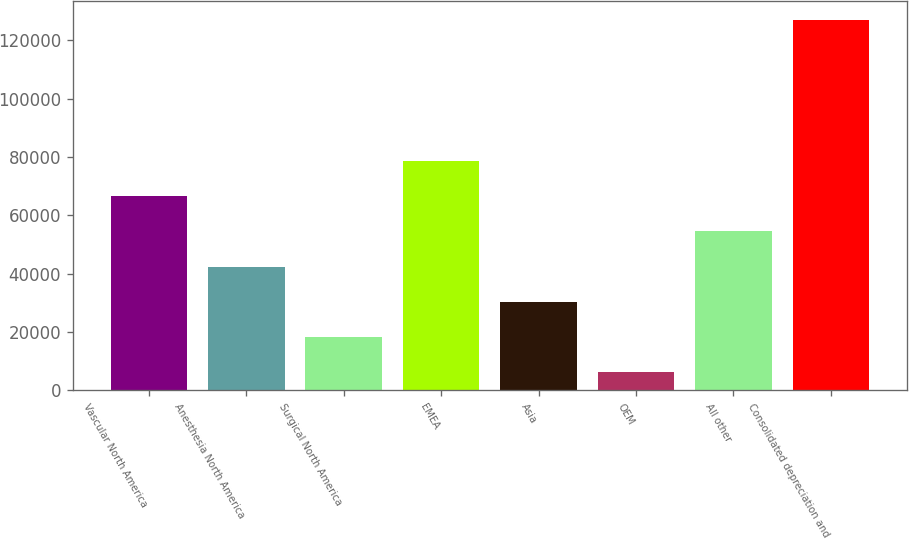Convert chart. <chart><loc_0><loc_0><loc_500><loc_500><bar_chart><fcel>Vascular North America<fcel>Anesthesia North America<fcel>Surgical North America<fcel>EMEA<fcel>Asia<fcel>OEM<fcel>All other<fcel>Consolidated depreciation and<nl><fcel>66602.5<fcel>42431.5<fcel>18260.5<fcel>78688<fcel>30346<fcel>6175<fcel>54517<fcel>127030<nl></chart> 